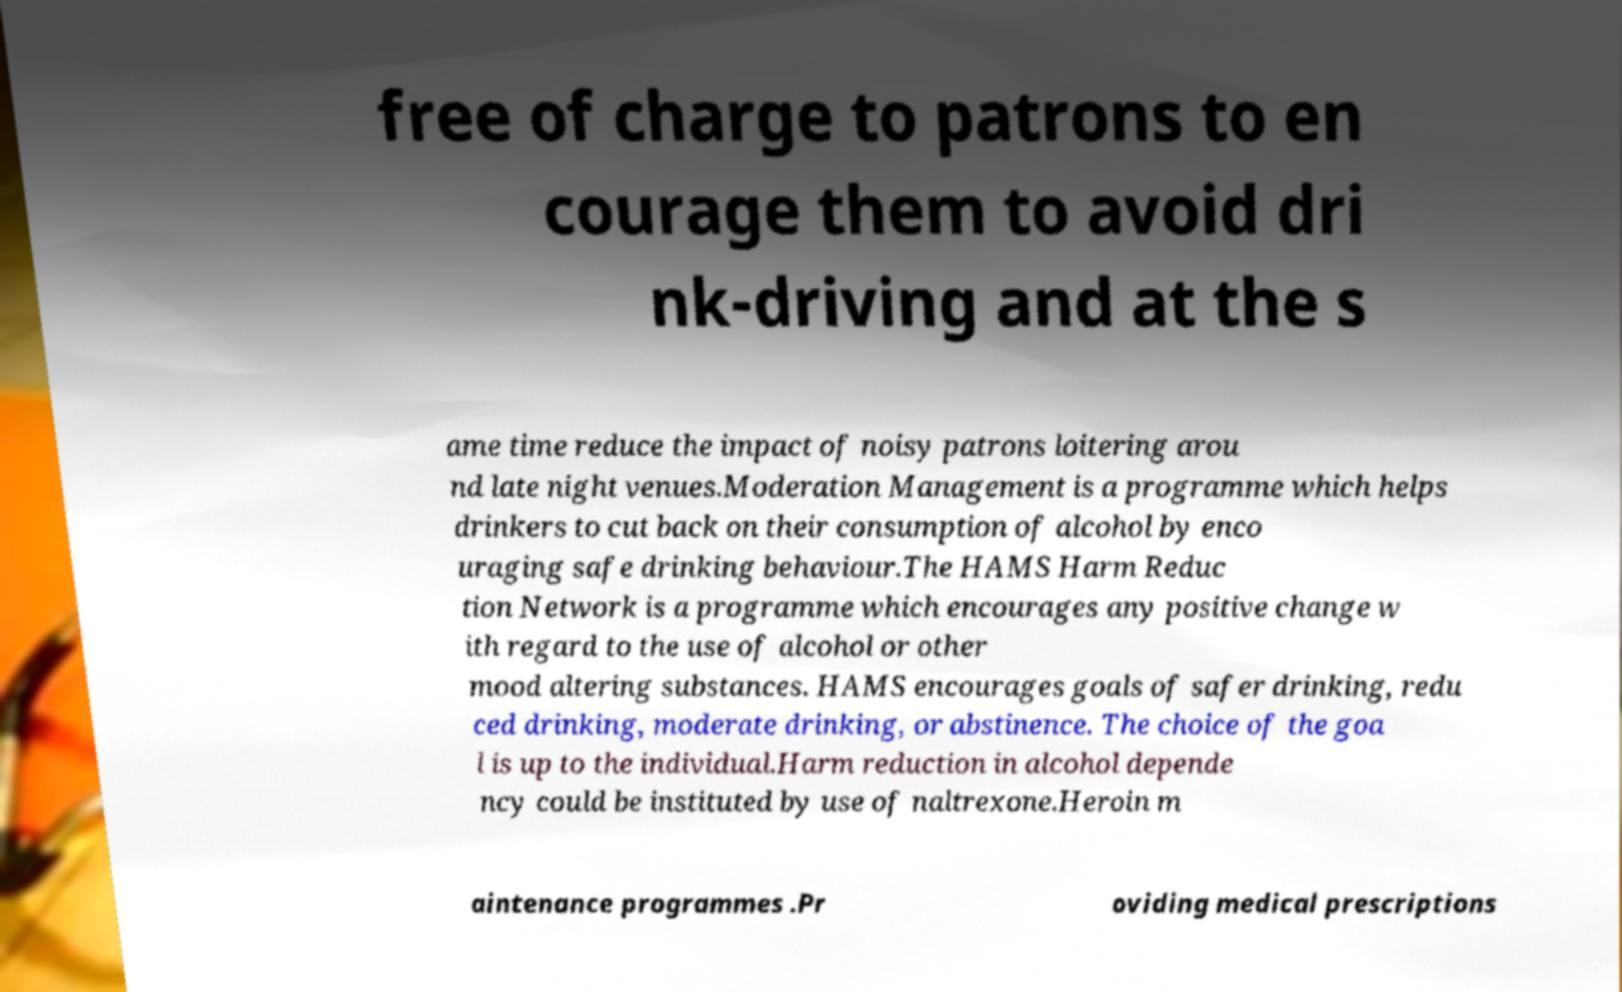There's text embedded in this image that I need extracted. Can you transcribe it verbatim? free of charge to patrons to en courage them to avoid dri nk-driving and at the s ame time reduce the impact of noisy patrons loitering arou nd late night venues.Moderation Management is a programme which helps drinkers to cut back on their consumption of alcohol by enco uraging safe drinking behaviour.The HAMS Harm Reduc tion Network is a programme which encourages any positive change w ith regard to the use of alcohol or other mood altering substances. HAMS encourages goals of safer drinking, redu ced drinking, moderate drinking, or abstinence. The choice of the goa l is up to the individual.Harm reduction in alcohol depende ncy could be instituted by use of naltrexone.Heroin m aintenance programmes .Pr oviding medical prescriptions 